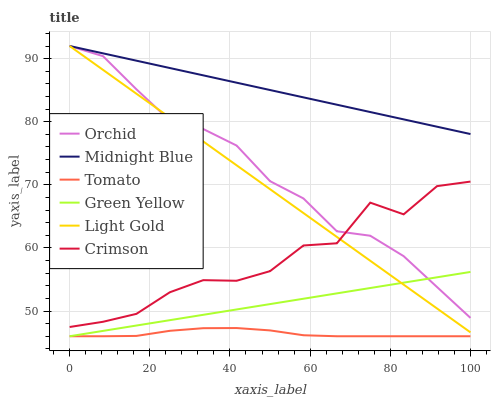Does Tomato have the minimum area under the curve?
Answer yes or no. Yes. Does Midnight Blue have the maximum area under the curve?
Answer yes or no. Yes. Does Crimson have the minimum area under the curve?
Answer yes or no. No. Does Crimson have the maximum area under the curve?
Answer yes or no. No. Is Green Yellow the smoothest?
Answer yes or no. Yes. Is Crimson the roughest?
Answer yes or no. Yes. Is Midnight Blue the smoothest?
Answer yes or no. No. Is Midnight Blue the roughest?
Answer yes or no. No. Does Crimson have the lowest value?
Answer yes or no. No. Does Orchid have the highest value?
Answer yes or no. Yes. Does Crimson have the highest value?
Answer yes or no. No. Is Crimson less than Midnight Blue?
Answer yes or no. Yes. Is Crimson greater than Green Yellow?
Answer yes or no. Yes. Does Crimson intersect Midnight Blue?
Answer yes or no. No. 